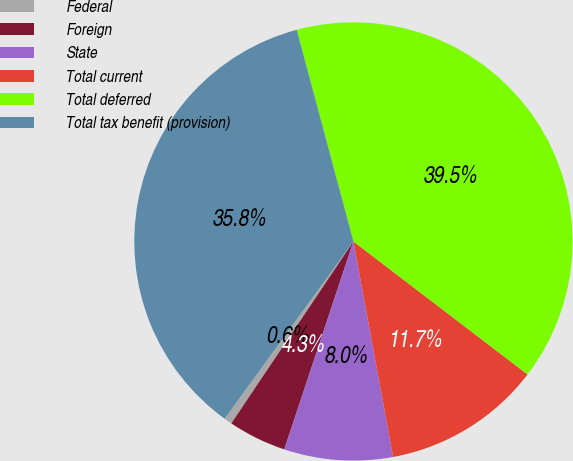Convert chart. <chart><loc_0><loc_0><loc_500><loc_500><pie_chart><fcel>Federal<fcel>Foreign<fcel>State<fcel>Total current<fcel>Total deferred<fcel>Total tax benefit (provision)<nl><fcel>0.59%<fcel>4.3%<fcel>8.01%<fcel>11.72%<fcel>39.55%<fcel>35.84%<nl></chart> 